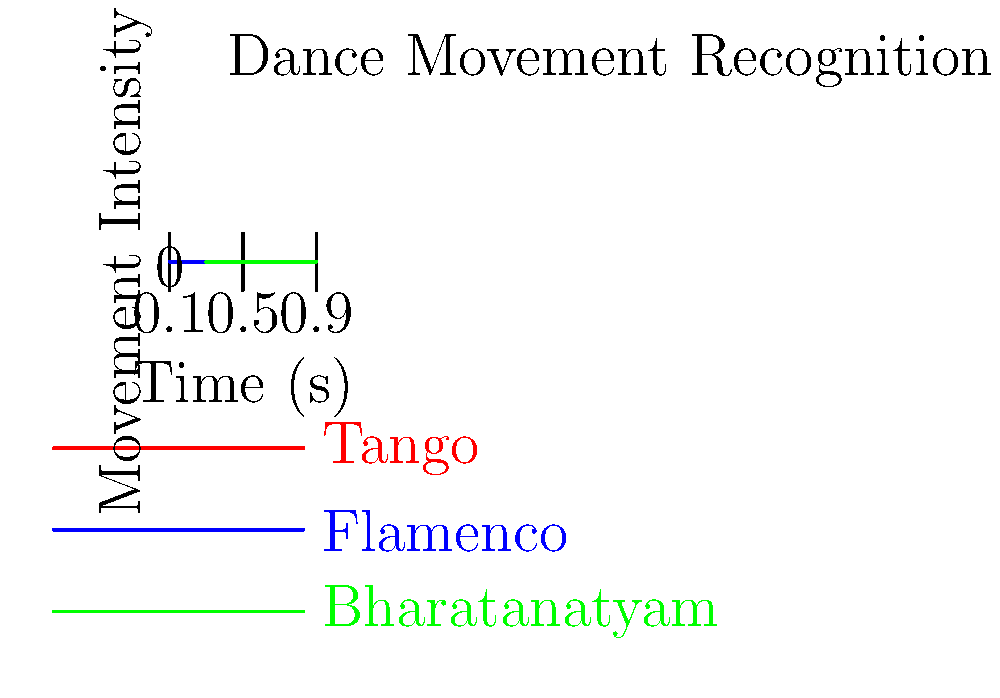Based on the graph showing movement intensity over time for three traditional dance styles, which dance form exhibits the highest overall movement intensity and would likely require the most advanced machine learning algorithms for accurate recognition from video frames? To determine which dance form exhibits the highest overall movement intensity and would likely require the most advanced machine learning algorithms for recognition, we need to analyze the graph:

1. Identify the three dance styles represented:
   - Red line: Tango
   - Blue line: Flamenco
   - Green line: Bharatanatyam

2. Observe the movement intensity patterns:
   - Tango: Relatively consistent, moderate intensity
   - Flamenco: High variability, with sharp peaks and valleys
   - Bharatanatyam: Consistently high intensity with less variability than Flamenco

3. Compare overall intensity levels:
   - Tango has the lowest overall intensity
   - Flamenco has high peaks but also low valleys
   - Bharatanatyam maintains the highest average intensity throughout

4. Consider complexity for machine learning recognition:
   - Higher intensity and more complex patterns require more sophisticated algorithms
   - Consistent high intensity with subtle variations (as in Bharatanatyam) can be challenging to differentiate

5. Conclusion:
   Bharatanatyam shows the highest overall movement intensity and would likely require the most advanced machine learning algorithms for accurate recognition from video frames due to its consistently high intensity and subtle variations in movement.
Answer: Bharatanatyam 